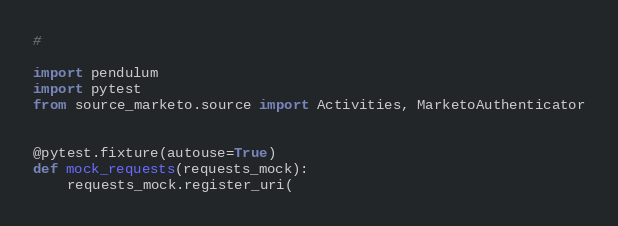<code> <loc_0><loc_0><loc_500><loc_500><_Python_>#

import pendulum
import pytest
from source_marketo.source import Activities, MarketoAuthenticator


@pytest.fixture(autouse=True)
def mock_requests(requests_mock):
    requests_mock.register_uri(</code> 